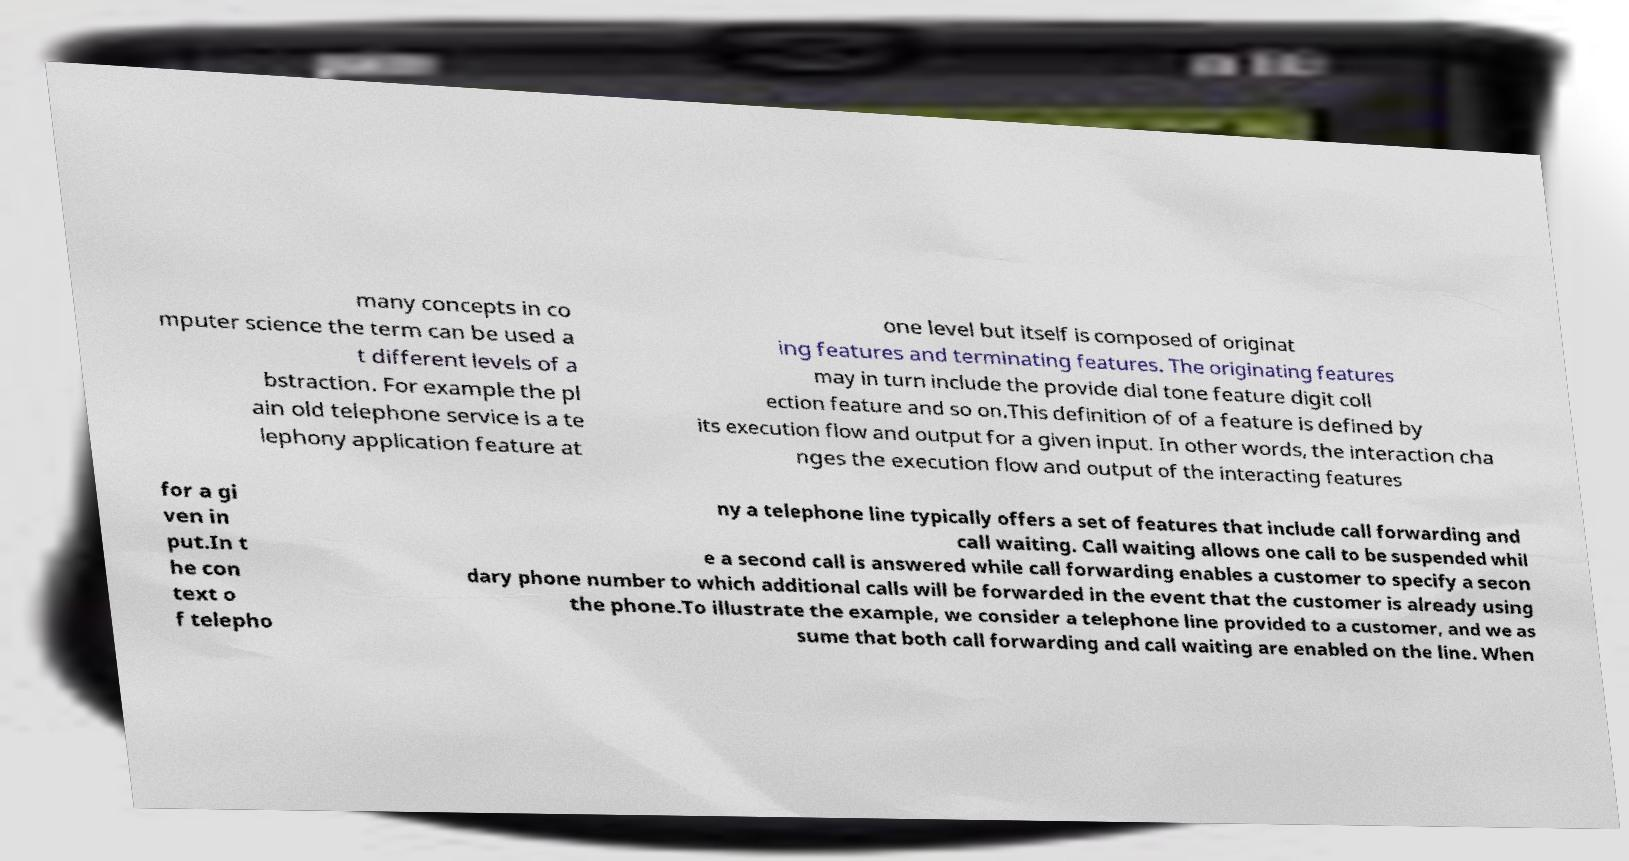There's text embedded in this image that I need extracted. Can you transcribe it verbatim? many concepts in co mputer science the term can be used a t different levels of a bstraction. For example the pl ain old telephone service is a te lephony application feature at one level but itself is composed of originat ing features and terminating features. The originating features may in turn include the provide dial tone feature digit coll ection feature and so on.This definition of of a feature is defined by its execution flow and output for a given input. In other words, the interaction cha nges the execution flow and output of the interacting features for a gi ven in put.In t he con text o f telepho ny a telephone line typically offers a set of features that include call forwarding and call waiting. Call waiting allows one call to be suspended whil e a second call is answered while call forwarding enables a customer to specify a secon dary phone number to which additional calls will be forwarded in the event that the customer is already using the phone.To illustrate the example, we consider a telephone line provided to a customer, and we as sume that both call forwarding and call waiting are enabled on the line. When 